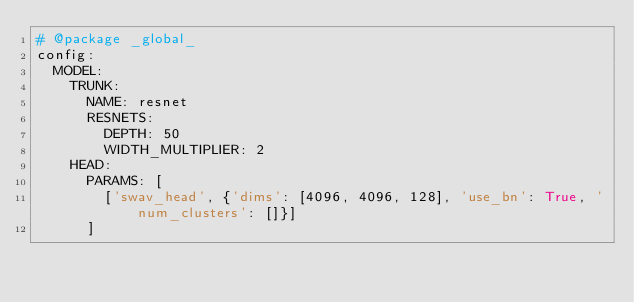Convert code to text. <code><loc_0><loc_0><loc_500><loc_500><_YAML_># @package _global_
config:
  MODEL:
    TRUNK:
      NAME: resnet
      RESNETS:
        DEPTH: 50
        WIDTH_MULTIPLIER: 2
    HEAD:
      PARAMS: [
        ['swav_head', {'dims': [4096, 4096, 128], 'use_bn': True, 'num_clusters': []}]
      ]
</code> 